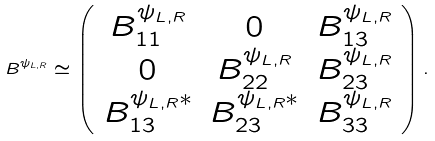Convert formula to latex. <formula><loc_0><loc_0><loc_500><loc_500>B ^ { \psi _ { L , R } } \simeq \left ( \begin{array} { c c c } B _ { 1 1 } ^ { \psi _ { L , R } } & 0 & B _ { 1 3 } ^ { \psi _ { L , R } } \\ 0 & B _ { 2 2 } ^ { \psi _ { L , R } } & B _ { 2 3 } ^ { \psi _ { L , R } } \\ B _ { 1 3 } ^ { \psi _ { L , R } * } & B _ { 2 3 } ^ { \psi _ { L , R } * } & B _ { 3 3 } ^ { \psi _ { L , R } } \end{array} \right ) .</formula> 